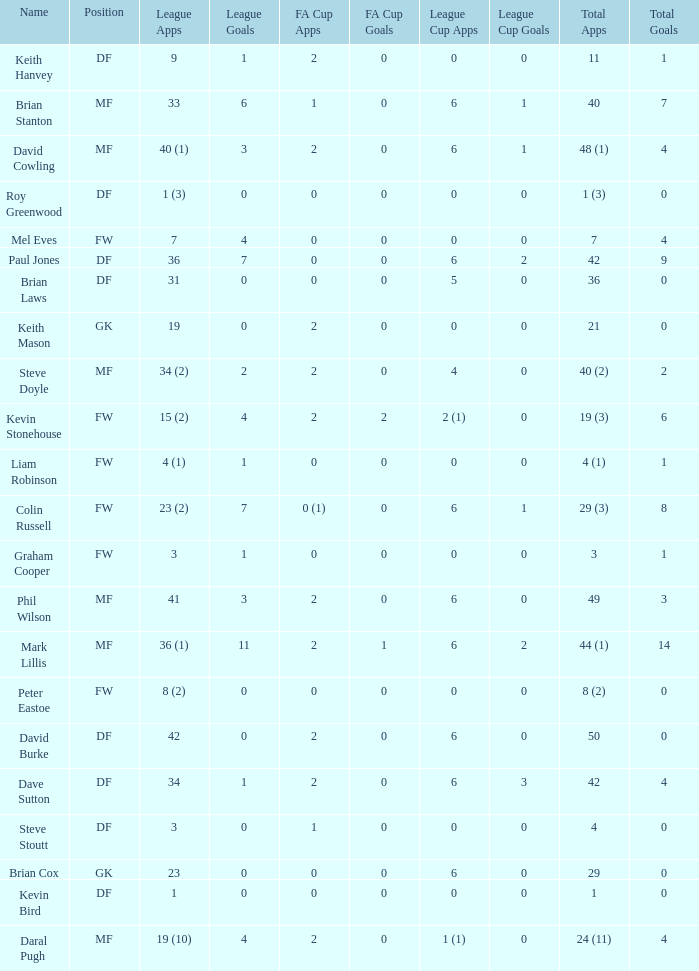What is the most total goals for a player having 0 FA Cup goals and 41 League appearances? 3.0. 